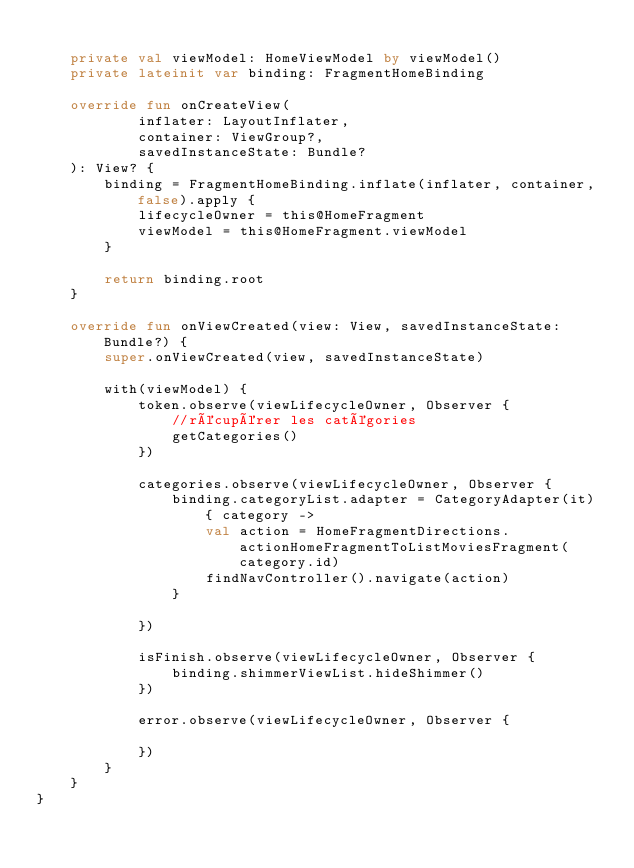Convert code to text. <code><loc_0><loc_0><loc_500><loc_500><_Kotlin_>
    private val viewModel: HomeViewModel by viewModel()
    private lateinit var binding: FragmentHomeBinding

    override fun onCreateView(
            inflater: LayoutInflater,
            container: ViewGroup?,
            savedInstanceState: Bundle?
    ): View? {
        binding = FragmentHomeBinding.inflate(inflater, container, false).apply {
            lifecycleOwner = this@HomeFragment
            viewModel = this@HomeFragment.viewModel
        }

        return binding.root
    }

    override fun onViewCreated(view: View, savedInstanceState: Bundle?) {
        super.onViewCreated(view, savedInstanceState)

        with(viewModel) {
            token.observe(viewLifecycleOwner, Observer {
                //récupérer les catégories
                getCategories()
            })

            categories.observe(viewLifecycleOwner, Observer {
                binding.categoryList.adapter = CategoryAdapter(it) { category ->
                    val action = HomeFragmentDirections.actionHomeFragmentToListMoviesFragment(category.id)
                    findNavController().navigate(action)
                }

            })

            isFinish.observe(viewLifecycleOwner, Observer {
                binding.shimmerViewList.hideShimmer()
            })

            error.observe(viewLifecycleOwner, Observer {

            })
        }
    }
}
</code> 